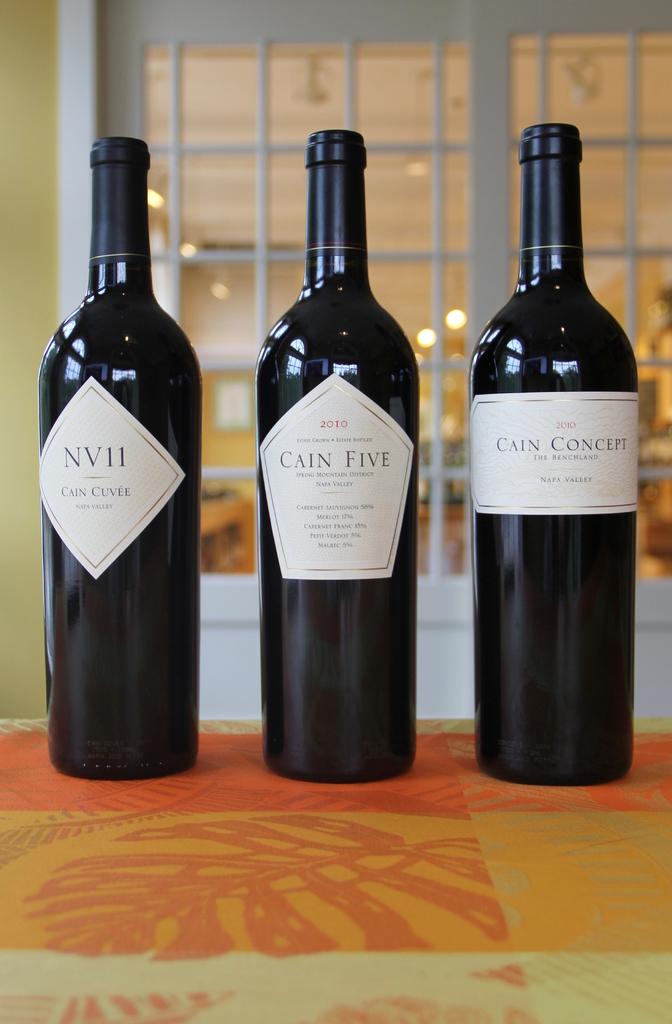What number is written out as part of the name on the center cain bottle?
Keep it short and to the point. Five. What year are these made in?
Your response must be concise. 2010. 